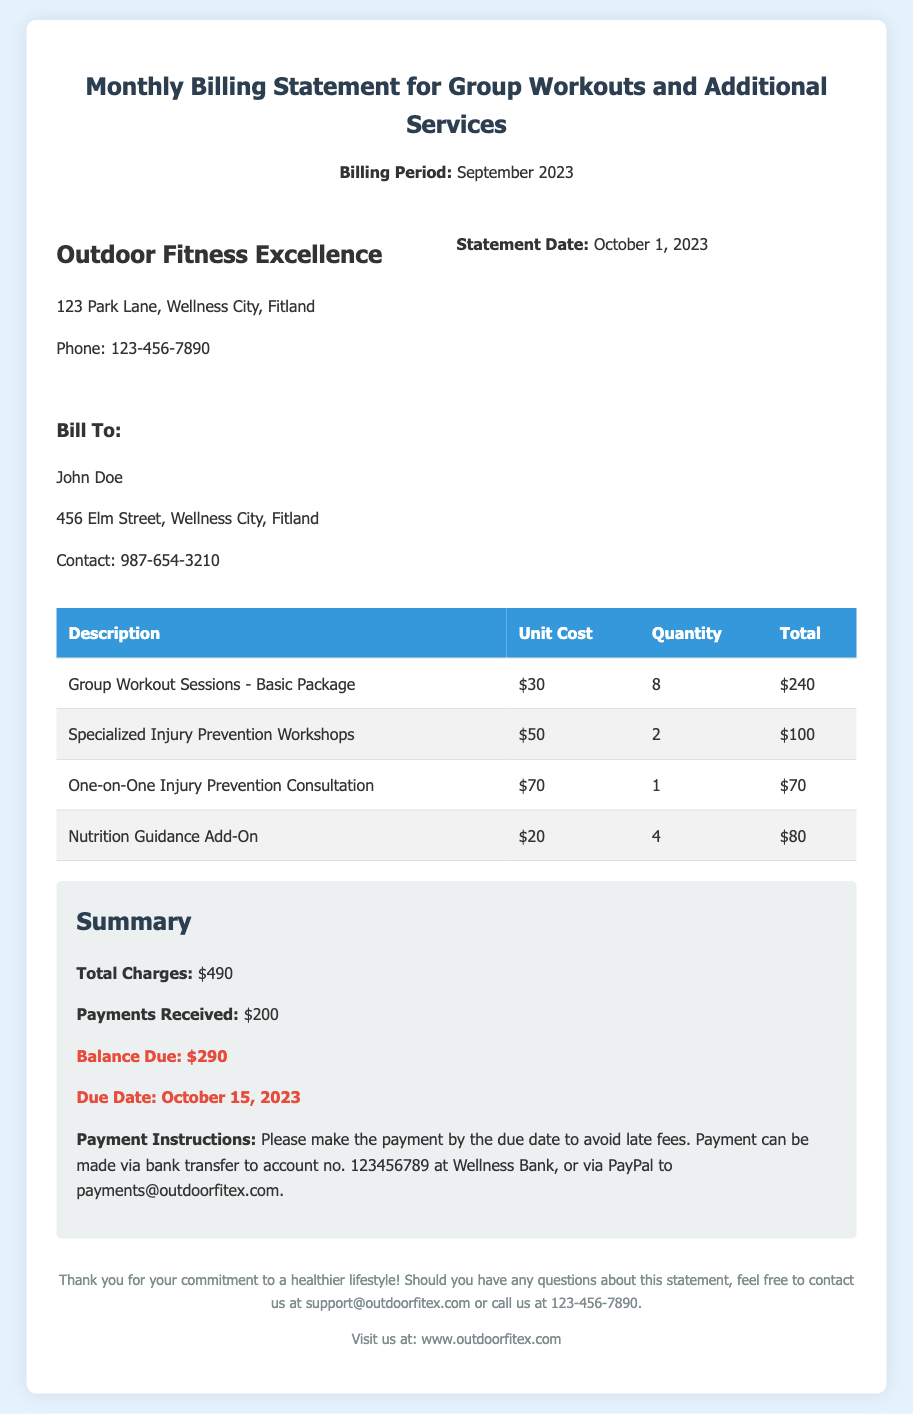What is the statement date? The statement date is explicitly stated in the documents, which is October 1, 2023.
Answer: October 1, 2023 What is the total balance due? The balance due is highlighted in the summary section and is indicated as $290.
Answer: $290 How many group workout sessions are included in the basic package? The number of group workout sessions for the basic package can be found under the "Quantity" column for that row, which states 8 sessions.
Answer: 8 What is the cost of the one-on-one injury prevention consultation? The cost is specified in the document as $70 under the "Unit Cost" column for that service.
Answer: $70 When is the payment due date? The due date is mentioned in the summary section, which states that the payment is due on October 15, 2023.
Answer: October 15, 2023 How many specialized injury prevention workshops were held? The number of workshops is listed in the "Quantity" column for that specific service, which shows 2 workshops.
Answer: 2 What is the total charge for nutrition guidance add-on? The total for the nutrition guidance add-on can be calculated by multiplying the unit cost by the quantity, which is $80.
Answer: $80 What is the main purpose of this document? The document serves as a billing statement for group workouts and additional services provided in the billing period.
Answer: Monthly Billing Statement 